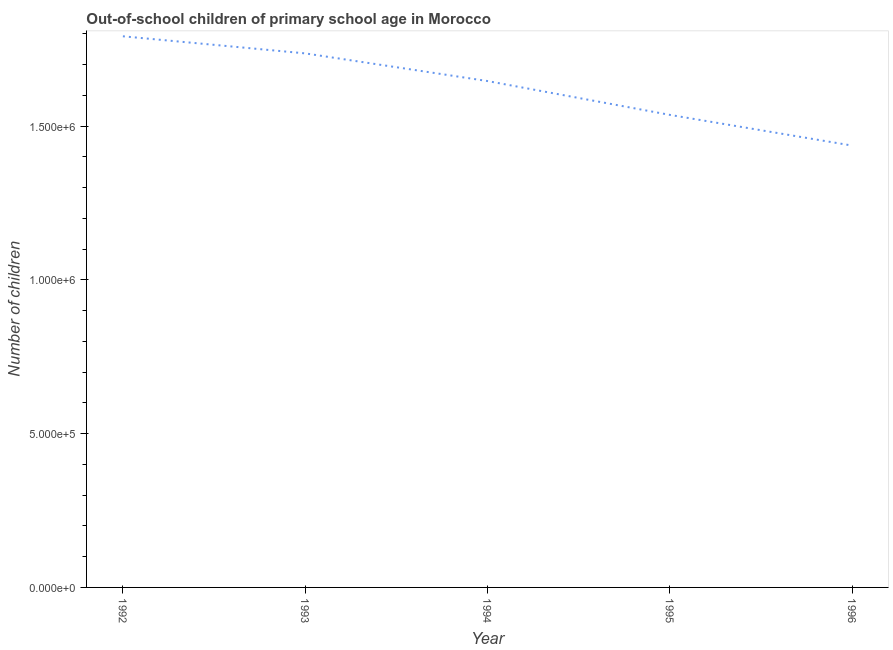What is the number of out-of-school children in 1995?
Provide a short and direct response. 1.54e+06. Across all years, what is the maximum number of out-of-school children?
Offer a terse response. 1.79e+06. Across all years, what is the minimum number of out-of-school children?
Your answer should be very brief. 1.44e+06. In which year was the number of out-of-school children minimum?
Keep it short and to the point. 1996. What is the sum of the number of out-of-school children?
Give a very brief answer. 8.15e+06. What is the difference between the number of out-of-school children in 1992 and 1995?
Your answer should be compact. 2.55e+05. What is the average number of out-of-school children per year?
Keep it short and to the point. 1.63e+06. What is the median number of out-of-school children?
Provide a succinct answer. 1.65e+06. In how many years, is the number of out-of-school children greater than 1200000 ?
Provide a short and direct response. 5. What is the ratio of the number of out-of-school children in 1994 to that in 1995?
Your response must be concise. 1.07. Is the number of out-of-school children in 1992 less than that in 1996?
Keep it short and to the point. No. Is the difference between the number of out-of-school children in 1995 and 1996 greater than the difference between any two years?
Your answer should be very brief. No. What is the difference between the highest and the second highest number of out-of-school children?
Make the answer very short. 5.56e+04. What is the difference between the highest and the lowest number of out-of-school children?
Your response must be concise. 3.55e+05. Does the number of out-of-school children monotonically increase over the years?
Keep it short and to the point. No. How many years are there in the graph?
Offer a terse response. 5. What is the difference between two consecutive major ticks on the Y-axis?
Offer a terse response. 5.00e+05. What is the title of the graph?
Keep it short and to the point. Out-of-school children of primary school age in Morocco. What is the label or title of the Y-axis?
Offer a terse response. Number of children. What is the Number of children in 1992?
Offer a very short reply. 1.79e+06. What is the Number of children in 1993?
Offer a terse response. 1.74e+06. What is the Number of children in 1994?
Provide a short and direct response. 1.65e+06. What is the Number of children in 1995?
Give a very brief answer. 1.54e+06. What is the Number of children of 1996?
Your answer should be very brief. 1.44e+06. What is the difference between the Number of children in 1992 and 1993?
Offer a very short reply. 5.56e+04. What is the difference between the Number of children in 1992 and 1994?
Keep it short and to the point. 1.46e+05. What is the difference between the Number of children in 1992 and 1995?
Give a very brief answer. 2.55e+05. What is the difference between the Number of children in 1992 and 1996?
Provide a short and direct response. 3.55e+05. What is the difference between the Number of children in 1993 and 1994?
Provide a short and direct response. 8.99e+04. What is the difference between the Number of children in 1993 and 1995?
Provide a succinct answer. 2.00e+05. What is the difference between the Number of children in 1993 and 1996?
Give a very brief answer. 3.00e+05. What is the difference between the Number of children in 1994 and 1995?
Keep it short and to the point. 1.10e+05. What is the difference between the Number of children in 1994 and 1996?
Your response must be concise. 2.10e+05. What is the difference between the Number of children in 1995 and 1996?
Ensure brevity in your answer.  9.98e+04. What is the ratio of the Number of children in 1992 to that in 1993?
Your response must be concise. 1.03. What is the ratio of the Number of children in 1992 to that in 1994?
Provide a succinct answer. 1.09. What is the ratio of the Number of children in 1992 to that in 1995?
Provide a short and direct response. 1.17. What is the ratio of the Number of children in 1992 to that in 1996?
Provide a short and direct response. 1.25. What is the ratio of the Number of children in 1993 to that in 1994?
Your response must be concise. 1.05. What is the ratio of the Number of children in 1993 to that in 1995?
Offer a very short reply. 1.13. What is the ratio of the Number of children in 1993 to that in 1996?
Your answer should be very brief. 1.21. What is the ratio of the Number of children in 1994 to that in 1995?
Your answer should be compact. 1.07. What is the ratio of the Number of children in 1994 to that in 1996?
Provide a short and direct response. 1.15. What is the ratio of the Number of children in 1995 to that in 1996?
Offer a terse response. 1.07. 